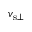Convert formula to latex. <formula><loc_0><loc_0><loc_500><loc_500>v _ { { s } \bot }</formula> 